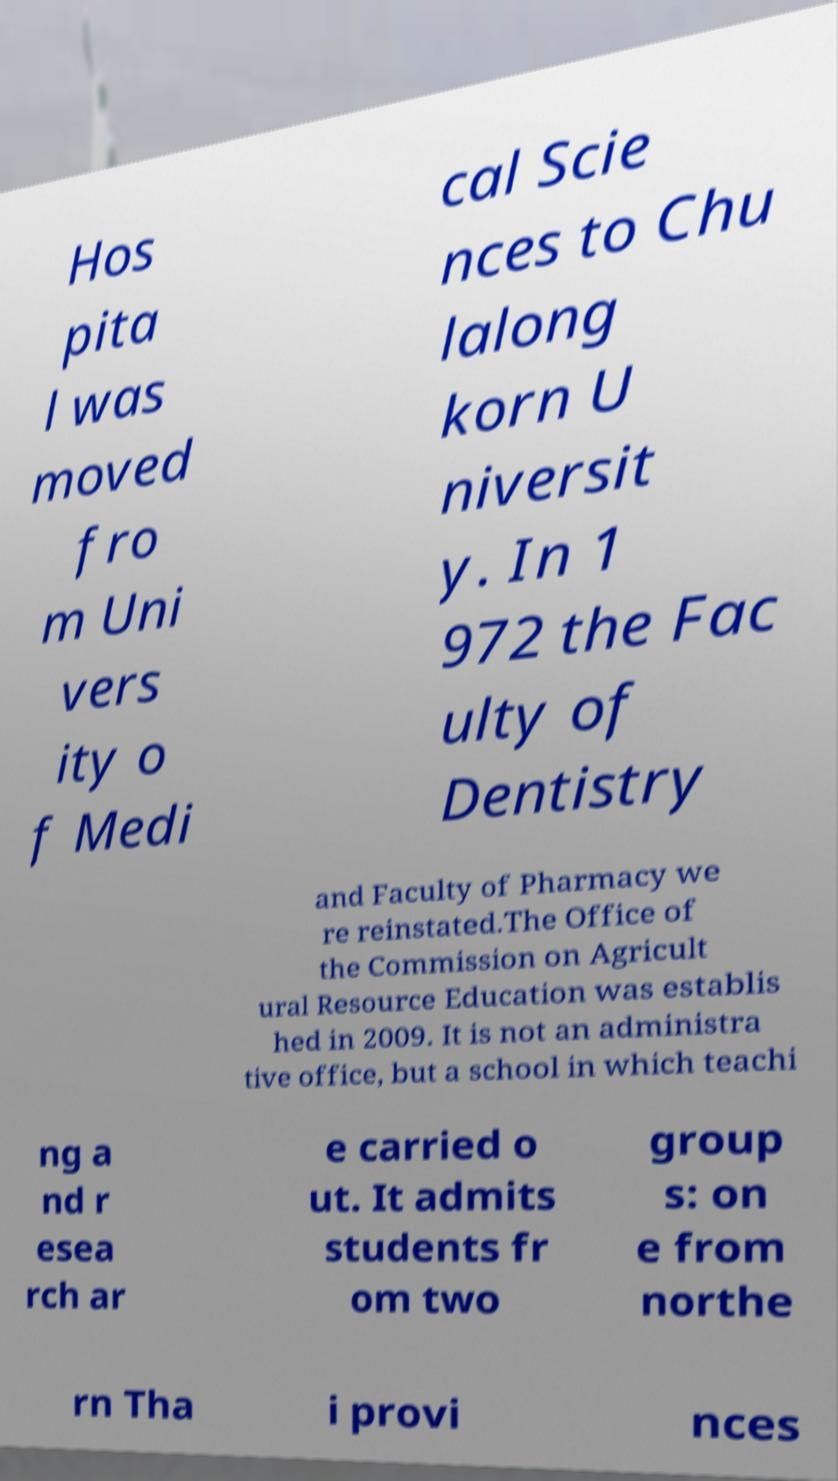I need the written content from this picture converted into text. Can you do that? Hos pita l was moved fro m Uni vers ity o f Medi cal Scie nces to Chu lalong korn U niversit y. In 1 972 the Fac ulty of Dentistry and Faculty of Pharmacy we re reinstated.The Office of the Commission on Agricult ural Resource Education was establis hed in 2009. It is not an administra tive office, but a school in which teachi ng a nd r esea rch ar e carried o ut. It admits students fr om two group s: on e from northe rn Tha i provi nces 